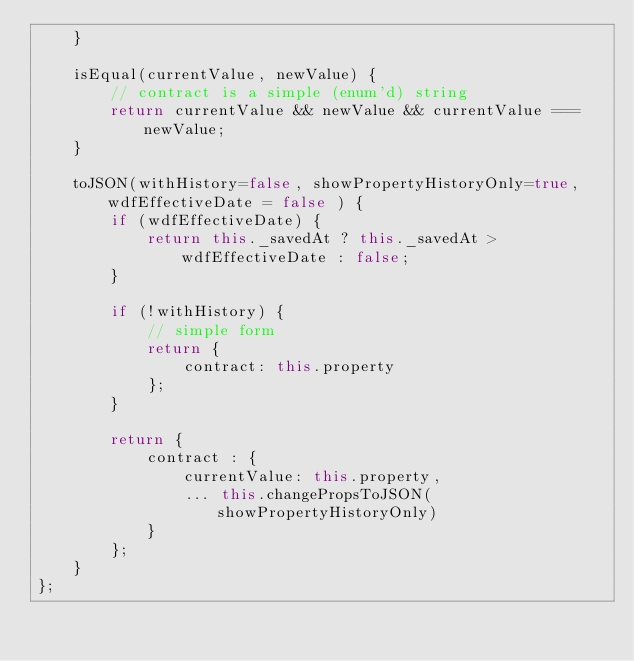<code> <loc_0><loc_0><loc_500><loc_500><_JavaScript_>    }

    isEqual(currentValue, newValue) {
        // contract is a simple (enum'd) string
        return currentValue && newValue && currentValue === newValue;
    }

    toJSON(withHistory=false, showPropertyHistoryOnly=true, wdfEffectiveDate = false ) {
        if (wdfEffectiveDate) {
            return this._savedAt ? this._savedAt > wdfEffectiveDate : false;
        }

        if (!withHistory) {
            // simple form
            return {
                contract: this.property
            };
        }

        return {
            contract : {
                currentValue: this.property,
                ... this.changePropsToJSON(showPropertyHistoryOnly)
            }
        };
    }
};</code> 